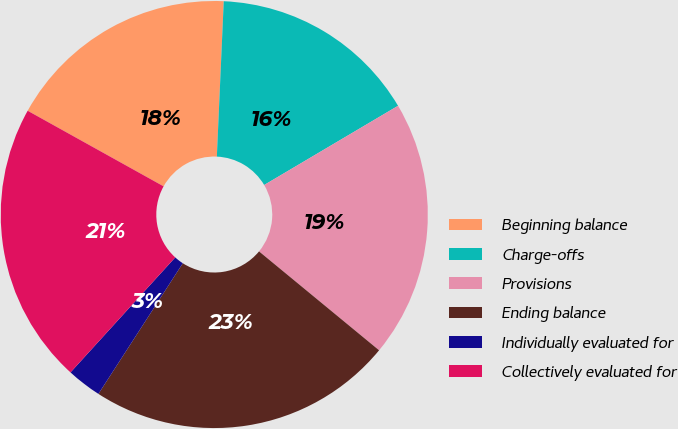Convert chart to OTSL. <chart><loc_0><loc_0><loc_500><loc_500><pie_chart><fcel>Beginning balance<fcel>Charge-offs<fcel>Provisions<fcel>Ending balance<fcel>Individually evaluated for<fcel>Collectively evaluated for<nl><fcel>17.63%<fcel>15.79%<fcel>19.47%<fcel>23.16%<fcel>2.63%<fcel>21.32%<nl></chart> 